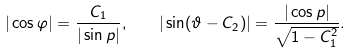Convert formula to latex. <formula><loc_0><loc_0><loc_500><loc_500>| \cos \varphi | = \frac { C _ { 1 } } { | \sin p | } , \quad | \sin ( \vartheta - C _ { 2 } ) | = \frac { | \cos p | } { \sqrt { 1 - C _ { 1 } ^ { 2 } } } .</formula> 